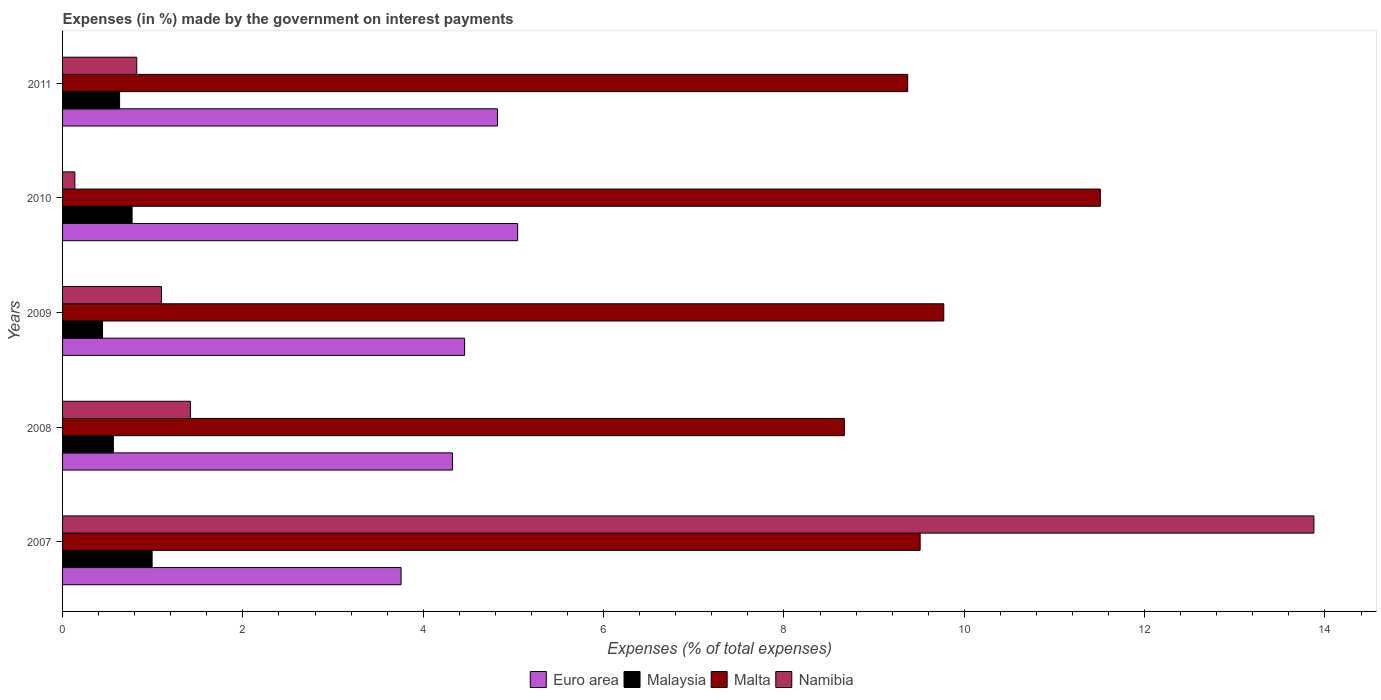How many groups of bars are there?
Your response must be concise. 5. Are the number of bars per tick equal to the number of legend labels?
Provide a succinct answer. Yes. Are the number of bars on each tick of the Y-axis equal?
Give a very brief answer. Yes. What is the label of the 5th group of bars from the top?
Provide a succinct answer. 2007. In how many cases, is the number of bars for a given year not equal to the number of legend labels?
Make the answer very short. 0. What is the percentage of expenses made by the government on interest payments in Malta in 2009?
Your answer should be compact. 9.77. Across all years, what is the maximum percentage of expenses made by the government on interest payments in Namibia?
Keep it short and to the point. 13.88. Across all years, what is the minimum percentage of expenses made by the government on interest payments in Malaysia?
Ensure brevity in your answer.  0.44. In which year was the percentage of expenses made by the government on interest payments in Namibia minimum?
Offer a terse response. 2010. What is the total percentage of expenses made by the government on interest payments in Euro area in the graph?
Provide a succinct answer. 22.41. What is the difference between the percentage of expenses made by the government on interest payments in Namibia in 2008 and that in 2009?
Offer a terse response. 0.32. What is the difference between the percentage of expenses made by the government on interest payments in Malaysia in 2009 and the percentage of expenses made by the government on interest payments in Namibia in 2008?
Provide a succinct answer. -0.97. What is the average percentage of expenses made by the government on interest payments in Namibia per year?
Give a very brief answer. 3.47. In the year 2011, what is the difference between the percentage of expenses made by the government on interest payments in Namibia and percentage of expenses made by the government on interest payments in Euro area?
Make the answer very short. -4. In how many years, is the percentage of expenses made by the government on interest payments in Malaysia greater than 11.6 %?
Your answer should be compact. 0. What is the ratio of the percentage of expenses made by the government on interest payments in Malaysia in 2008 to that in 2009?
Offer a terse response. 1.27. What is the difference between the highest and the second highest percentage of expenses made by the government on interest payments in Malaysia?
Your answer should be very brief. 0.22. What is the difference between the highest and the lowest percentage of expenses made by the government on interest payments in Malta?
Give a very brief answer. 2.84. In how many years, is the percentage of expenses made by the government on interest payments in Malta greater than the average percentage of expenses made by the government on interest payments in Malta taken over all years?
Your answer should be very brief. 2. Is the sum of the percentage of expenses made by the government on interest payments in Malaysia in 2009 and 2011 greater than the maximum percentage of expenses made by the government on interest payments in Malta across all years?
Your answer should be compact. No. What does the 3rd bar from the top in 2009 represents?
Your response must be concise. Malaysia. What does the 3rd bar from the bottom in 2011 represents?
Your answer should be very brief. Malta. Is it the case that in every year, the sum of the percentage of expenses made by the government on interest payments in Malaysia and percentage of expenses made by the government on interest payments in Namibia is greater than the percentage of expenses made by the government on interest payments in Euro area?
Your answer should be compact. No. How many bars are there?
Your answer should be compact. 20. What is the difference between two consecutive major ticks on the X-axis?
Keep it short and to the point. 2. Does the graph contain grids?
Give a very brief answer. No. How many legend labels are there?
Provide a short and direct response. 4. What is the title of the graph?
Offer a very short reply. Expenses (in %) made by the government on interest payments. Does "Jamaica" appear as one of the legend labels in the graph?
Your response must be concise. No. What is the label or title of the X-axis?
Give a very brief answer. Expenses (% of total expenses). What is the Expenses (% of total expenses) in Euro area in 2007?
Your answer should be compact. 3.75. What is the Expenses (% of total expenses) of Malaysia in 2007?
Provide a succinct answer. 0.99. What is the Expenses (% of total expenses) in Malta in 2007?
Make the answer very short. 9.51. What is the Expenses (% of total expenses) in Namibia in 2007?
Make the answer very short. 13.88. What is the Expenses (% of total expenses) of Euro area in 2008?
Provide a short and direct response. 4.32. What is the Expenses (% of total expenses) of Malaysia in 2008?
Your answer should be compact. 0.56. What is the Expenses (% of total expenses) in Malta in 2008?
Your answer should be compact. 8.67. What is the Expenses (% of total expenses) of Namibia in 2008?
Offer a very short reply. 1.42. What is the Expenses (% of total expenses) in Euro area in 2009?
Keep it short and to the point. 4.46. What is the Expenses (% of total expenses) in Malaysia in 2009?
Keep it short and to the point. 0.44. What is the Expenses (% of total expenses) in Malta in 2009?
Ensure brevity in your answer.  9.77. What is the Expenses (% of total expenses) of Namibia in 2009?
Make the answer very short. 1.1. What is the Expenses (% of total expenses) of Euro area in 2010?
Offer a very short reply. 5.05. What is the Expenses (% of total expenses) in Malaysia in 2010?
Your response must be concise. 0.77. What is the Expenses (% of total expenses) in Malta in 2010?
Provide a succinct answer. 11.51. What is the Expenses (% of total expenses) in Namibia in 2010?
Give a very brief answer. 0.14. What is the Expenses (% of total expenses) in Euro area in 2011?
Provide a short and direct response. 4.82. What is the Expenses (% of total expenses) of Malaysia in 2011?
Your answer should be very brief. 0.63. What is the Expenses (% of total expenses) in Malta in 2011?
Offer a terse response. 9.37. What is the Expenses (% of total expenses) in Namibia in 2011?
Your answer should be compact. 0.82. Across all years, what is the maximum Expenses (% of total expenses) of Euro area?
Give a very brief answer. 5.05. Across all years, what is the maximum Expenses (% of total expenses) of Malaysia?
Provide a short and direct response. 0.99. Across all years, what is the maximum Expenses (% of total expenses) of Malta?
Offer a very short reply. 11.51. Across all years, what is the maximum Expenses (% of total expenses) in Namibia?
Your answer should be very brief. 13.88. Across all years, what is the minimum Expenses (% of total expenses) of Euro area?
Provide a short and direct response. 3.75. Across all years, what is the minimum Expenses (% of total expenses) of Malaysia?
Your answer should be very brief. 0.44. Across all years, what is the minimum Expenses (% of total expenses) in Malta?
Your response must be concise. 8.67. Across all years, what is the minimum Expenses (% of total expenses) of Namibia?
Offer a terse response. 0.14. What is the total Expenses (% of total expenses) of Euro area in the graph?
Your answer should be very brief. 22.41. What is the total Expenses (% of total expenses) in Malaysia in the graph?
Give a very brief answer. 3.4. What is the total Expenses (% of total expenses) of Malta in the graph?
Offer a very short reply. 48.83. What is the total Expenses (% of total expenses) in Namibia in the graph?
Offer a terse response. 17.35. What is the difference between the Expenses (% of total expenses) in Euro area in 2007 and that in 2008?
Offer a terse response. -0.57. What is the difference between the Expenses (% of total expenses) in Malaysia in 2007 and that in 2008?
Make the answer very short. 0.43. What is the difference between the Expenses (% of total expenses) in Malta in 2007 and that in 2008?
Ensure brevity in your answer.  0.84. What is the difference between the Expenses (% of total expenses) of Namibia in 2007 and that in 2008?
Give a very brief answer. 12.46. What is the difference between the Expenses (% of total expenses) in Euro area in 2007 and that in 2009?
Keep it short and to the point. -0.7. What is the difference between the Expenses (% of total expenses) of Malaysia in 2007 and that in 2009?
Offer a very short reply. 0.55. What is the difference between the Expenses (% of total expenses) in Malta in 2007 and that in 2009?
Ensure brevity in your answer.  -0.26. What is the difference between the Expenses (% of total expenses) in Namibia in 2007 and that in 2009?
Make the answer very short. 12.78. What is the difference between the Expenses (% of total expenses) of Euro area in 2007 and that in 2010?
Your response must be concise. -1.29. What is the difference between the Expenses (% of total expenses) of Malaysia in 2007 and that in 2010?
Your answer should be compact. 0.22. What is the difference between the Expenses (% of total expenses) in Malta in 2007 and that in 2010?
Offer a very short reply. -2. What is the difference between the Expenses (% of total expenses) of Namibia in 2007 and that in 2010?
Ensure brevity in your answer.  13.74. What is the difference between the Expenses (% of total expenses) in Euro area in 2007 and that in 2011?
Make the answer very short. -1.07. What is the difference between the Expenses (% of total expenses) in Malaysia in 2007 and that in 2011?
Offer a very short reply. 0.36. What is the difference between the Expenses (% of total expenses) of Malta in 2007 and that in 2011?
Provide a short and direct response. 0.14. What is the difference between the Expenses (% of total expenses) in Namibia in 2007 and that in 2011?
Your answer should be compact. 13.06. What is the difference between the Expenses (% of total expenses) in Euro area in 2008 and that in 2009?
Provide a short and direct response. -0.13. What is the difference between the Expenses (% of total expenses) in Malaysia in 2008 and that in 2009?
Provide a short and direct response. 0.12. What is the difference between the Expenses (% of total expenses) of Malta in 2008 and that in 2009?
Your response must be concise. -1.1. What is the difference between the Expenses (% of total expenses) of Namibia in 2008 and that in 2009?
Make the answer very short. 0.32. What is the difference between the Expenses (% of total expenses) of Euro area in 2008 and that in 2010?
Provide a succinct answer. -0.72. What is the difference between the Expenses (% of total expenses) of Malaysia in 2008 and that in 2010?
Offer a terse response. -0.21. What is the difference between the Expenses (% of total expenses) in Malta in 2008 and that in 2010?
Offer a very short reply. -2.84. What is the difference between the Expenses (% of total expenses) in Namibia in 2008 and that in 2010?
Your response must be concise. 1.28. What is the difference between the Expenses (% of total expenses) in Euro area in 2008 and that in 2011?
Provide a succinct answer. -0.5. What is the difference between the Expenses (% of total expenses) of Malaysia in 2008 and that in 2011?
Make the answer very short. -0.07. What is the difference between the Expenses (% of total expenses) of Malta in 2008 and that in 2011?
Your answer should be compact. -0.7. What is the difference between the Expenses (% of total expenses) of Namibia in 2008 and that in 2011?
Your answer should be very brief. 0.59. What is the difference between the Expenses (% of total expenses) of Euro area in 2009 and that in 2010?
Provide a succinct answer. -0.59. What is the difference between the Expenses (% of total expenses) of Malaysia in 2009 and that in 2010?
Give a very brief answer. -0.33. What is the difference between the Expenses (% of total expenses) in Malta in 2009 and that in 2010?
Your response must be concise. -1.74. What is the difference between the Expenses (% of total expenses) in Namibia in 2009 and that in 2010?
Provide a short and direct response. 0.96. What is the difference between the Expenses (% of total expenses) in Euro area in 2009 and that in 2011?
Provide a succinct answer. -0.36. What is the difference between the Expenses (% of total expenses) in Malaysia in 2009 and that in 2011?
Make the answer very short. -0.19. What is the difference between the Expenses (% of total expenses) in Malta in 2009 and that in 2011?
Make the answer very short. 0.4. What is the difference between the Expenses (% of total expenses) in Namibia in 2009 and that in 2011?
Your response must be concise. 0.27. What is the difference between the Expenses (% of total expenses) in Euro area in 2010 and that in 2011?
Make the answer very short. 0.22. What is the difference between the Expenses (% of total expenses) of Malaysia in 2010 and that in 2011?
Your answer should be compact. 0.14. What is the difference between the Expenses (% of total expenses) of Malta in 2010 and that in 2011?
Your answer should be very brief. 2.14. What is the difference between the Expenses (% of total expenses) in Namibia in 2010 and that in 2011?
Offer a very short reply. -0.69. What is the difference between the Expenses (% of total expenses) of Euro area in 2007 and the Expenses (% of total expenses) of Malaysia in 2008?
Keep it short and to the point. 3.19. What is the difference between the Expenses (% of total expenses) in Euro area in 2007 and the Expenses (% of total expenses) in Malta in 2008?
Your response must be concise. -4.92. What is the difference between the Expenses (% of total expenses) of Euro area in 2007 and the Expenses (% of total expenses) of Namibia in 2008?
Offer a very short reply. 2.34. What is the difference between the Expenses (% of total expenses) of Malaysia in 2007 and the Expenses (% of total expenses) of Malta in 2008?
Ensure brevity in your answer.  -7.68. What is the difference between the Expenses (% of total expenses) of Malaysia in 2007 and the Expenses (% of total expenses) of Namibia in 2008?
Your response must be concise. -0.42. What is the difference between the Expenses (% of total expenses) of Malta in 2007 and the Expenses (% of total expenses) of Namibia in 2008?
Provide a succinct answer. 8.09. What is the difference between the Expenses (% of total expenses) in Euro area in 2007 and the Expenses (% of total expenses) in Malaysia in 2009?
Provide a succinct answer. 3.31. What is the difference between the Expenses (% of total expenses) in Euro area in 2007 and the Expenses (% of total expenses) in Malta in 2009?
Provide a short and direct response. -6.02. What is the difference between the Expenses (% of total expenses) in Euro area in 2007 and the Expenses (% of total expenses) in Namibia in 2009?
Your answer should be very brief. 2.66. What is the difference between the Expenses (% of total expenses) of Malaysia in 2007 and the Expenses (% of total expenses) of Malta in 2009?
Provide a short and direct response. -8.78. What is the difference between the Expenses (% of total expenses) of Malaysia in 2007 and the Expenses (% of total expenses) of Namibia in 2009?
Your answer should be compact. -0.1. What is the difference between the Expenses (% of total expenses) of Malta in 2007 and the Expenses (% of total expenses) of Namibia in 2009?
Offer a terse response. 8.41. What is the difference between the Expenses (% of total expenses) of Euro area in 2007 and the Expenses (% of total expenses) of Malaysia in 2010?
Ensure brevity in your answer.  2.98. What is the difference between the Expenses (% of total expenses) in Euro area in 2007 and the Expenses (% of total expenses) in Malta in 2010?
Offer a very short reply. -7.75. What is the difference between the Expenses (% of total expenses) in Euro area in 2007 and the Expenses (% of total expenses) in Namibia in 2010?
Your answer should be very brief. 3.62. What is the difference between the Expenses (% of total expenses) of Malaysia in 2007 and the Expenses (% of total expenses) of Malta in 2010?
Provide a succinct answer. -10.52. What is the difference between the Expenses (% of total expenses) of Malaysia in 2007 and the Expenses (% of total expenses) of Namibia in 2010?
Your answer should be very brief. 0.86. What is the difference between the Expenses (% of total expenses) of Malta in 2007 and the Expenses (% of total expenses) of Namibia in 2010?
Ensure brevity in your answer.  9.37. What is the difference between the Expenses (% of total expenses) of Euro area in 2007 and the Expenses (% of total expenses) of Malaysia in 2011?
Give a very brief answer. 3.12. What is the difference between the Expenses (% of total expenses) of Euro area in 2007 and the Expenses (% of total expenses) of Malta in 2011?
Your answer should be very brief. -5.62. What is the difference between the Expenses (% of total expenses) of Euro area in 2007 and the Expenses (% of total expenses) of Namibia in 2011?
Your answer should be compact. 2.93. What is the difference between the Expenses (% of total expenses) in Malaysia in 2007 and the Expenses (% of total expenses) in Malta in 2011?
Give a very brief answer. -8.38. What is the difference between the Expenses (% of total expenses) in Malaysia in 2007 and the Expenses (% of total expenses) in Namibia in 2011?
Provide a succinct answer. 0.17. What is the difference between the Expenses (% of total expenses) of Malta in 2007 and the Expenses (% of total expenses) of Namibia in 2011?
Provide a short and direct response. 8.69. What is the difference between the Expenses (% of total expenses) in Euro area in 2008 and the Expenses (% of total expenses) in Malaysia in 2009?
Provide a short and direct response. 3.88. What is the difference between the Expenses (% of total expenses) in Euro area in 2008 and the Expenses (% of total expenses) in Malta in 2009?
Ensure brevity in your answer.  -5.45. What is the difference between the Expenses (% of total expenses) of Euro area in 2008 and the Expenses (% of total expenses) of Namibia in 2009?
Offer a very short reply. 3.23. What is the difference between the Expenses (% of total expenses) of Malaysia in 2008 and the Expenses (% of total expenses) of Malta in 2009?
Keep it short and to the point. -9.21. What is the difference between the Expenses (% of total expenses) in Malaysia in 2008 and the Expenses (% of total expenses) in Namibia in 2009?
Keep it short and to the point. -0.53. What is the difference between the Expenses (% of total expenses) of Malta in 2008 and the Expenses (% of total expenses) of Namibia in 2009?
Keep it short and to the point. 7.57. What is the difference between the Expenses (% of total expenses) in Euro area in 2008 and the Expenses (% of total expenses) in Malaysia in 2010?
Your answer should be very brief. 3.55. What is the difference between the Expenses (% of total expenses) of Euro area in 2008 and the Expenses (% of total expenses) of Malta in 2010?
Your answer should be compact. -7.18. What is the difference between the Expenses (% of total expenses) of Euro area in 2008 and the Expenses (% of total expenses) of Namibia in 2010?
Ensure brevity in your answer.  4.19. What is the difference between the Expenses (% of total expenses) in Malaysia in 2008 and the Expenses (% of total expenses) in Malta in 2010?
Your answer should be compact. -10.95. What is the difference between the Expenses (% of total expenses) of Malaysia in 2008 and the Expenses (% of total expenses) of Namibia in 2010?
Provide a succinct answer. 0.43. What is the difference between the Expenses (% of total expenses) in Malta in 2008 and the Expenses (% of total expenses) in Namibia in 2010?
Give a very brief answer. 8.53. What is the difference between the Expenses (% of total expenses) of Euro area in 2008 and the Expenses (% of total expenses) of Malaysia in 2011?
Make the answer very short. 3.69. What is the difference between the Expenses (% of total expenses) of Euro area in 2008 and the Expenses (% of total expenses) of Malta in 2011?
Offer a terse response. -5.05. What is the difference between the Expenses (% of total expenses) in Euro area in 2008 and the Expenses (% of total expenses) in Namibia in 2011?
Provide a short and direct response. 3.5. What is the difference between the Expenses (% of total expenses) in Malaysia in 2008 and the Expenses (% of total expenses) in Malta in 2011?
Give a very brief answer. -8.81. What is the difference between the Expenses (% of total expenses) in Malaysia in 2008 and the Expenses (% of total expenses) in Namibia in 2011?
Keep it short and to the point. -0.26. What is the difference between the Expenses (% of total expenses) of Malta in 2008 and the Expenses (% of total expenses) of Namibia in 2011?
Ensure brevity in your answer.  7.85. What is the difference between the Expenses (% of total expenses) in Euro area in 2009 and the Expenses (% of total expenses) in Malaysia in 2010?
Make the answer very short. 3.69. What is the difference between the Expenses (% of total expenses) in Euro area in 2009 and the Expenses (% of total expenses) in Malta in 2010?
Offer a very short reply. -7.05. What is the difference between the Expenses (% of total expenses) of Euro area in 2009 and the Expenses (% of total expenses) of Namibia in 2010?
Offer a terse response. 4.32. What is the difference between the Expenses (% of total expenses) of Malaysia in 2009 and the Expenses (% of total expenses) of Malta in 2010?
Give a very brief answer. -11.07. What is the difference between the Expenses (% of total expenses) in Malaysia in 2009 and the Expenses (% of total expenses) in Namibia in 2010?
Offer a very short reply. 0.31. What is the difference between the Expenses (% of total expenses) in Malta in 2009 and the Expenses (% of total expenses) in Namibia in 2010?
Provide a short and direct response. 9.64. What is the difference between the Expenses (% of total expenses) of Euro area in 2009 and the Expenses (% of total expenses) of Malaysia in 2011?
Give a very brief answer. 3.83. What is the difference between the Expenses (% of total expenses) of Euro area in 2009 and the Expenses (% of total expenses) of Malta in 2011?
Provide a succinct answer. -4.91. What is the difference between the Expenses (% of total expenses) in Euro area in 2009 and the Expenses (% of total expenses) in Namibia in 2011?
Provide a short and direct response. 3.64. What is the difference between the Expenses (% of total expenses) of Malaysia in 2009 and the Expenses (% of total expenses) of Malta in 2011?
Keep it short and to the point. -8.93. What is the difference between the Expenses (% of total expenses) of Malaysia in 2009 and the Expenses (% of total expenses) of Namibia in 2011?
Offer a terse response. -0.38. What is the difference between the Expenses (% of total expenses) of Malta in 2009 and the Expenses (% of total expenses) of Namibia in 2011?
Ensure brevity in your answer.  8.95. What is the difference between the Expenses (% of total expenses) of Euro area in 2010 and the Expenses (% of total expenses) of Malaysia in 2011?
Give a very brief answer. 4.41. What is the difference between the Expenses (% of total expenses) of Euro area in 2010 and the Expenses (% of total expenses) of Malta in 2011?
Offer a very short reply. -4.33. What is the difference between the Expenses (% of total expenses) of Euro area in 2010 and the Expenses (% of total expenses) of Namibia in 2011?
Offer a very short reply. 4.22. What is the difference between the Expenses (% of total expenses) of Malaysia in 2010 and the Expenses (% of total expenses) of Malta in 2011?
Ensure brevity in your answer.  -8.6. What is the difference between the Expenses (% of total expenses) in Malaysia in 2010 and the Expenses (% of total expenses) in Namibia in 2011?
Provide a short and direct response. -0.05. What is the difference between the Expenses (% of total expenses) in Malta in 2010 and the Expenses (% of total expenses) in Namibia in 2011?
Provide a short and direct response. 10.69. What is the average Expenses (% of total expenses) of Euro area per year?
Provide a short and direct response. 4.48. What is the average Expenses (% of total expenses) of Malaysia per year?
Keep it short and to the point. 0.68. What is the average Expenses (% of total expenses) of Malta per year?
Keep it short and to the point. 9.77. What is the average Expenses (% of total expenses) in Namibia per year?
Offer a very short reply. 3.47. In the year 2007, what is the difference between the Expenses (% of total expenses) in Euro area and Expenses (% of total expenses) in Malaysia?
Offer a terse response. 2.76. In the year 2007, what is the difference between the Expenses (% of total expenses) in Euro area and Expenses (% of total expenses) in Malta?
Offer a terse response. -5.76. In the year 2007, what is the difference between the Expenses (% of total expenses) in Euro area and Expenses (% of total expenses) in Namibia?
Your response must be concise. -10.12. In the year 2007, what is the difference between the Expenses (% of total expenses) of Malaysia and Expenses (% of total expenses) of Malta?
Provide a short and direct response. -8.52. In the year 2007, what is the difference between the Expenses (% of total expenses) of Malaysia and Expenses (% of total expenses) of Namibia?
Your answer should be compact. -12.88. In the year 2007, what is the difference between the Expenses (% of total expenses) in Malta and Expenses (% of total expenses) in Namibia?
Offer a terse response. -4.37. In the year 2008, what is the difference between the Expenses (% of total expenses) in Euro area and Expenses (% of total expenses) in Malaysia?
Provide a succinct answer. 3.76. In the year 2008, what is the difference between the Expenses (% of total expenses) of Euro area and Expenses (% of total expenses) of Malta?
Offer a very short reply. -4.35. In the year 2008, what is the difference between the Expenses (% of total expenses) in Euro area and Expenses (% of total expenses) in Namibia?
Ensure brevity in your answer.  2.91. In the year 2008, what is the difference between the Expenses (% of total expenses) of Malaysia and Expenses (% of total expenses) of Malta?
Your answer should be very brief. -8.11. In the year 2008, what is the difference between the Expenses (% of total expenses) of Malaysia and Expenses (% of total expenses) of Namibia?
Offer a terse response. -0.85. In the year 2008, what is the difference between the Expenses (% of total expenses) in Malta and Expenses (% of total expenses) in Namibia?
Offer a terse response. 7.25. In the year 2009, what is the difference between the Expenses (% of total expenses) in Euro area and Expenses (% of total expenses) in Malaysia?
Make the answer very short. 4.02. In the year 2009, what is the difference between the Expenses (% of total expenses) in Euro area and Expenses (% of total expenses) in Malta?
Give a very brief answer. -5.31. In the year 2009, what is the difference between the Expenses (% of total expenses) of Euro area and Expenses (% of total expenses) of Namibia?
Provide a short and direct response. 3.36. In the year 2009, what is the difference between the Expenses (% of total expenses) of Malaysia and Expenses (% of total expenses) of Malta?
Your answer should be very brief. -9.33. In the year 2009, what is the difference between the Expenses (% of total expenses) in Malaysia and Expenses (% of total expenses) in Namibia?
Provide a short and direct response. -0.65. In the year 2009, what is the difference between the Expenses (% of total expenses) in Malta and Expenses (% of total expenses) in Namibia?
Ensure brevity in your answer.  8.68. In the year 2010, what is the difference between the Expenses (% of total expenses) of Euro area and Expenses (% of total expenses) of Malaysia?
Ensure brevity in your answer.  4.28. In the year 2010, what is the difference between the Expenses (% of total expenses) of Euro area and Expenses (% of total expenses) of Malta?
Keep it short and to the point. -6.46. In the year 2010, what is the difference between the Expenses (% of total expenses) in Euro area and Expenses (% of total expenses) in Namibia?
Your response must be concise. 4.91. In the year 2010, what is the difference between the Expenses (% of total expenses) of Malaysia and Expenses (% of total expenses) of Malta?
Offer a terse response. -10.74. In the year 2010, what is the difference between the Expenses (% of total expenses) in Malaysia and Expenses (% of total expenses) in Namibia?
Your answer should be compact. 0.63. In the year 2010, what is the difference between the Expenses (% of total expenses) of Malta and Expenses (% of total expenses) of Namibia?
Keep it short and to the point. 11.37. In the year 2011, what is the difference between the Expenses (% of total expenses) of Euro area and Expenses (% of total expenses) of Malaysia?
Your response must be concise. 4.19. In the year 2011, what is the difference between the Expenses (% of total expenses) of Euro area and Expenses (% of total expenses) of Malta?
Make the answer very short. -4.55. In the year 2011, what is the difference between the Expenses (% of total expenses) of Euro area and Expenses (% of total expenses) of Namibia?
Offer a very short reply. 4. In the year 2011, what is the difference between the Expenses (% of total expenses) of Malaysia and Expenses (% of total expenses) of Malta?
Provide a short and direct response. -8.74. In the year 2011, what is the difference between the Expenses (% of total expenses) of Malaysia and Expenses (% of total expenses) of Namibia?
Your response must be concise. -0.19. In the year 2011, what is the difference between the Expenses (% of total expenses) of Malta and Expenses (% of total expenses) of Namibia?
Ensure brevity in your answer.  8.55. What is the ratio of the Expenses (% of total expenses) of Euro area in 2007 to that in 2008?
Provide a short and direct response. 0.87. What is the ratio of the Expenses (% of total expenses) in Malaysia in 2007 to that in 2008?
Your response must be concise. 1.76. What is the ratio of the Expenses (% of total expenses) in Malta in 2007 to that in 2008?
Offer a very short reply. 1.1. What is the ratio of the Expenses (% of total expenses) of Namibia in 2007 to that in 2008?
Your answer should be compact. 9.79. What is the ratio of the Expenses (% of total expenses) of Euro area in 2007 to that in 2009?
Your answer should be compact. 0.84. What is the ratio of the Expenses (% of total expenses) of Malaysia in 2007 to that in 2009?
Your answer should be compact. 2.24. What is the ratio of the Expenses (% of total expenses) in Malta in 2007 to that in 2009?
Your answer should be very brief. 0.97. What is the ratio of the Expenses (% of total expenses) of Namibia in 2007 to that in 2009?
Your response must be concise. 12.65. What is the ratio of the Expenses (% of total expenses) in Euro area in 2007 to that in 2010?
Offer a very short reply. 0.74. What is the ratio of the Expenses (% of total expenses) in Malaysia in 2007 to that in 2010?
Your answer should be compact. 1.29. What is the ratio of the Expenses (% of total expenses) in Malta in 2007 to that in 2010?
Keep it short and to the point. 0.83. What is the ratio of the Expenses (% of total expenses) in Namibia in 2007 to that in 2010?
Keep it short and to the point. 101.81. What is the ratio of the Expenses (% of total expenses) of Euro area in 2007 to that in 2011?
Your answer should be very brief. 0.78. What is the ratio of the Expenses (% of total expenses) in Malaysia in 2007 to that in 2011?
Make the answer very short. 1.57. What is the ratio of the Expenses (% of total expenses) of Malta in 2007 to that in 2011?
Ensure brevity in your answer.  1.01. What is the ratio of the Expenses (% of total expenses) in Namibia in 2007 to that in 2011?
Your answer should be very brief. 16.87. What is the ratio of the Expenses (% of total expenses) in Euro area in 2008 to that in 2009?
Offer a terse response. 0.97. What is the ratio of the Expenses (% of total expenses) in Malaysia in 2008 to that in 2009?
Provide a short and direct response. 1.27. What is the ratio of the Expenses (% of total expenses) in Malta in 2008 to that in 2009?
Your answer should be compact. 0.89. What is the ratio of the Expenses (% of total expenses) of Namibia in 2008 to that in 2009?
Your answer should be very brief. 1.29. What is the ratio of the Expenses (% of total expenses) in Euro area in 2008 to that in 2010?
Offer a terse response. 0.86. What is the ratio of the Expenses (% of total expenses) of Malaysia in 2008 to that in 2010?
Give a very brief answer. 0.73. What is the ratio of the Expenses (% of total expenses) of Malta in 2008 to that in 2010?
Keep it short and to the point. 0.75. What is the ratio of the Expenses (% of total expenses) in Namibia in 2008 to that in 2010?
Your response must be concise. 10.4. What is the ratio of the Expenses (% of total expenses) in Euro area in 2008 to that in 2011?
Give a very brief answer. 0.9. What is the ratio of the Expenses (% of total expenses) of Malaysia in 2008 to that in 2011?
Make the answer very short. 0.89. What is the ratio of the Expenses (% of total expenses) in Malta in 2008 to that in 2011?
Offer a terse response. 0.93. What is the ratio of the Expenses (% of total expenses) of Namibia in 2008 to that in 2011?
Ensure brevity in your answer.  1.72. What is the ratio of the Expenses (% of total expenses) in Euro area in 2009 to that in 2010?
Make the answer very short. 0.88. What is the ratio of the Expenses (% of total expenses) of Malaysia in 2009 to that in 2010?
Offer a very short reply. 0.57. What is the ratio of the Expenses (% of total expenses) in Malta in 2009 to that in 2010?
Ensure brevity in your answer.  0.85. What is the ratio of the Expenses (% of total expenses) in Namibia in 2009 to that in 2010?
Your answer should be very brief. 8.05. What is the ratio of the Expenses (% of total expenses) in Euro area in 2009 to that in 2011?
Your answer should be very brief. 0.92. What is the ratio of the Expenses (% of total expenses) of Malaysia in 2009 to that in 2011?
Offer a terse response. 0.7. What is the ratio of the Expenses (% of total expenses) of Malta in 2009 to that in 2011?
Provide a succinct answer. 1.04. What is the ratio of the Expenses (% of total expenses) in Namibia in 2009 to that in 2011?
Give a very brief answer. 1.33. What is the ratio of the Expenses (% of total expenses) in Euro area in 2010 to that in 2011?
Keep it short and to the point. 1.05. What is the ratio of the Expenses (% of total expenses) in Malaysia in 2010 to that in 2011?
Give a very brief answer. 1.22. What is the ratio of the Expenses (% of total expenses) in Malta in 2010 to that in 2011?
Provide a succinct answer. 1.23. What is the ratio of the Expenses (% of total expenses) of Namibia in 2010 to that in 2011?
Your answer should be compact. 0.17. What is the difference between the highest and the second highest Expenses (% of total expenses) in Euro area?
Keep it short and to the point. 0.22. What is the difference between the highest and the second highest Expenses (% of total expenses) in Malaysia?
Offer a very short reply. 0.22. What is the difference between the highest and the second highest Expenses (% of total expenses) of Malta?
Your answer should be very brief. 1.74. What is the difference between the highest and the second highest Expenses (% of total expenses) of Namibia?
Provide a succinct answer. 12.46. What is the difference between the highest and the lowest Expenses (% of total expenses) in Euro area?
Offer a terse response. 1.29. What is the difference between the highest and the lowest Expenses (% of total expenses) in Malaysia?
Your answer should be compact. 0.55. What is the difference between the highest and the lowest Expenses (% of total expenses) of Malta?
Make the answer very short. 2.84. What is the difference between the highest and the lowest Expenses (% of total expenses) in Namibia?
Give a very brief answer. 13.74. 